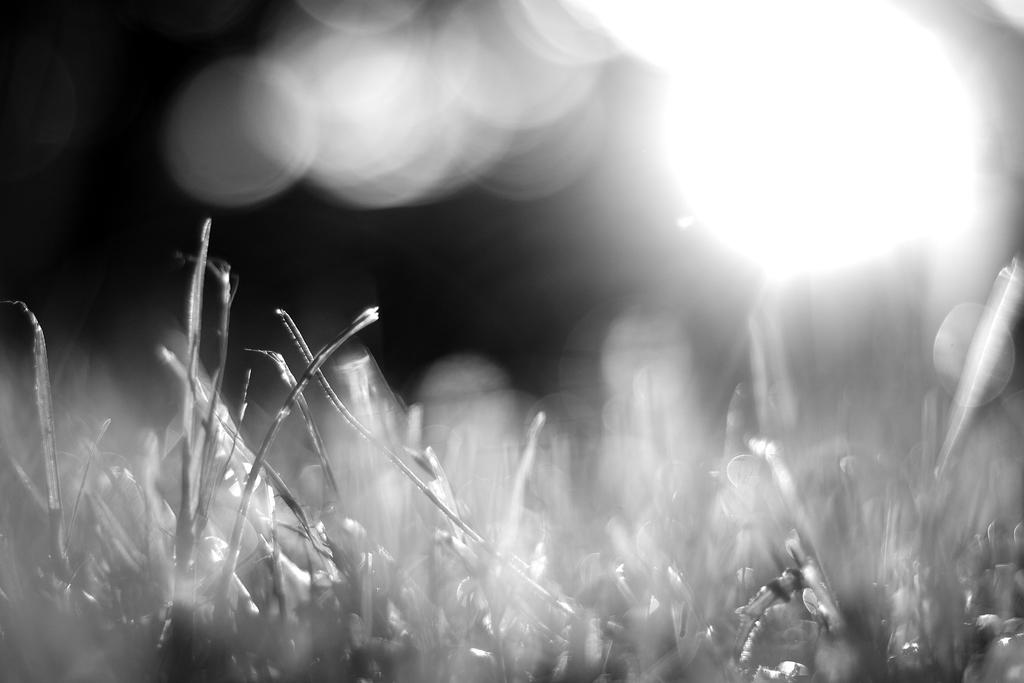What is the color scheme of the image? The image is black and white. What type of vegetation can be seen in the image? There is grass visible in the image. Can you describe the lighting in the image? There is light in the image. How many bubbles can be seen in the image? There are no bubbles present in the image. What type of camera was used to take the image? The image does not provide information about the camera used to take it. 